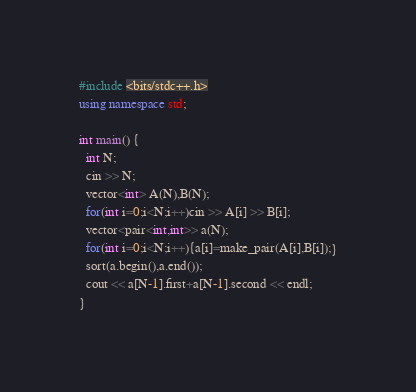<code> <loc_0><loc_0><loc_500><loc_500><_C++_>#include <bits/stdc++.h>
using namespace std;

int main() {
  int N;
  cin >> N;
  vector<int> A(N),B(N);
  for(int i=0;i<N;i++)cin >> A[i] >> B[i];
  vector<pair<int,int>> a(N);
  for(int i=0;i<N;i++){a[i]=make_pair(A[i],B[i]);}
  sort(a.begin(),a.end());
  cout << a[N-1].first+a[N-1].second << endl;
}</code> 